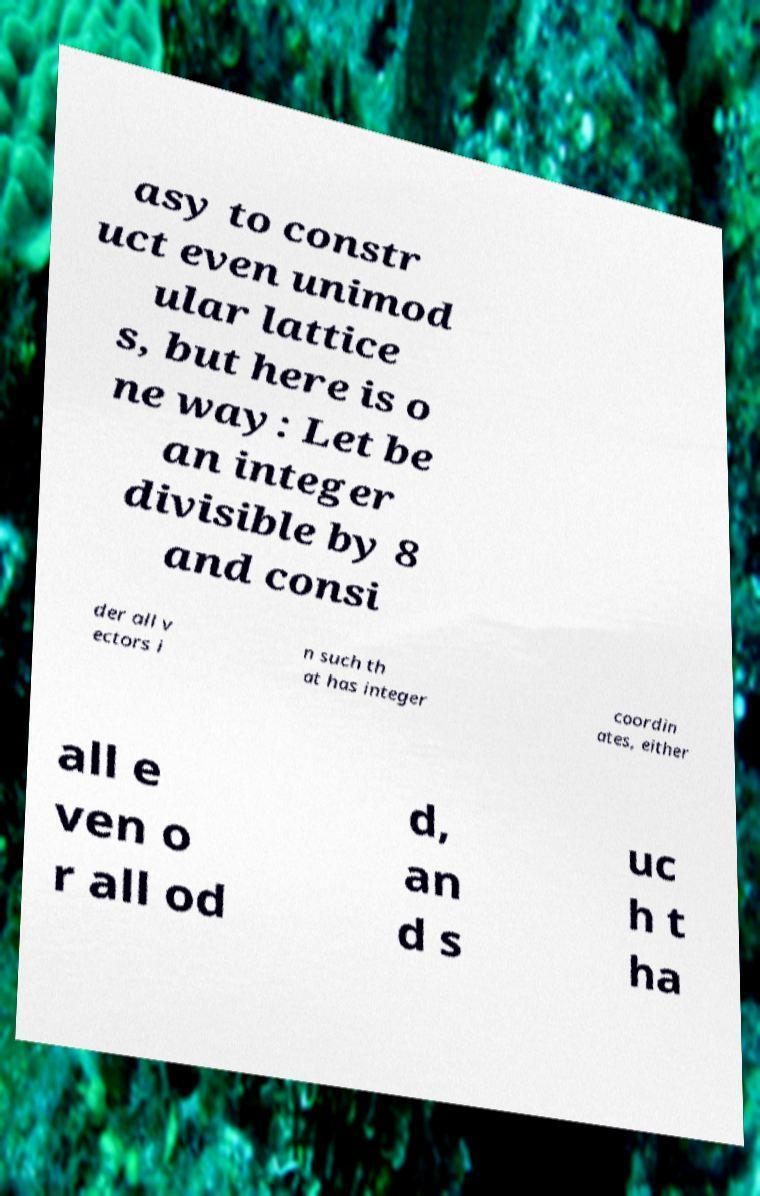For documentation purposes, I need the text within this image transcribed. Could you provide that? asy to constr uct even unimod ular lattice s, but here is o ne way: Let be an integer divisible by 8 and consi der all v ectors i n such th at has integer coordin ates, either all e ven o r all od d, an d s uc h t ha 